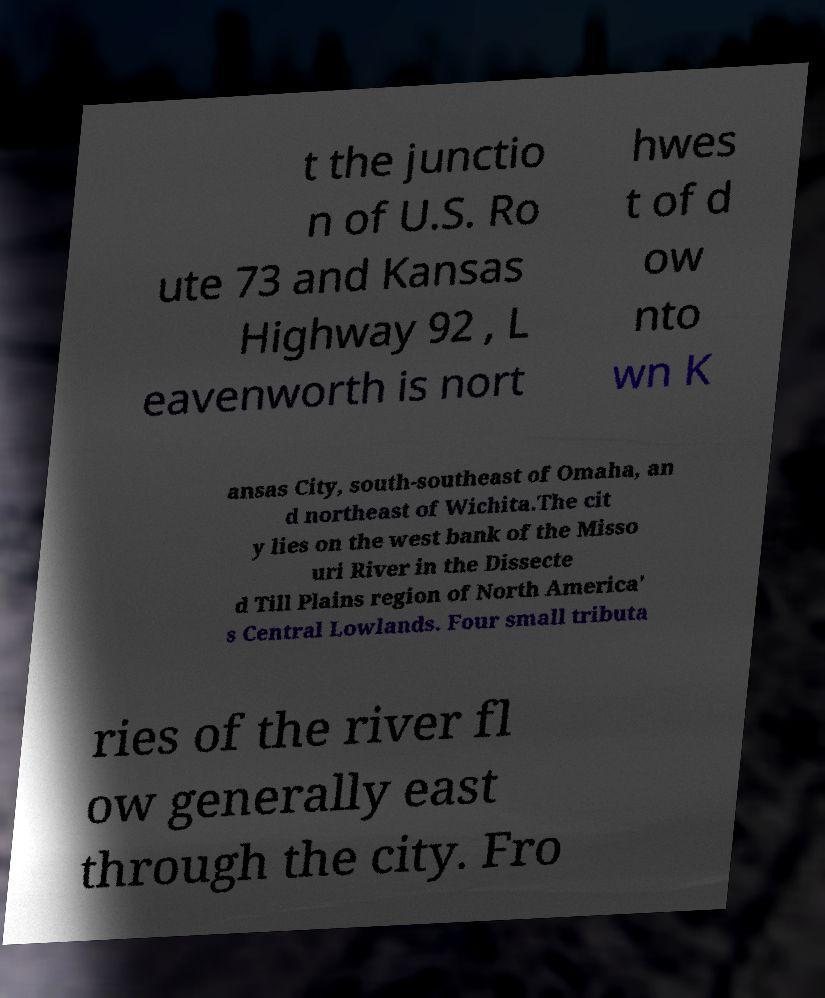Could you extract and type out the text from this image? t the junctio n of U.S. Ro ute 73 and Kansas Highway 92 , L eavenworth is nort hwes t of d ow nto wn K ansas City, south-southeast of Omaha, an d northeast of Wichita.The cit y lies on the west bank of the Misso uri River in the Dissecte d Till Plains region of North America' s Central Lowlands. Four small tributa ries of the river fl ow generally east through the city. Fro 